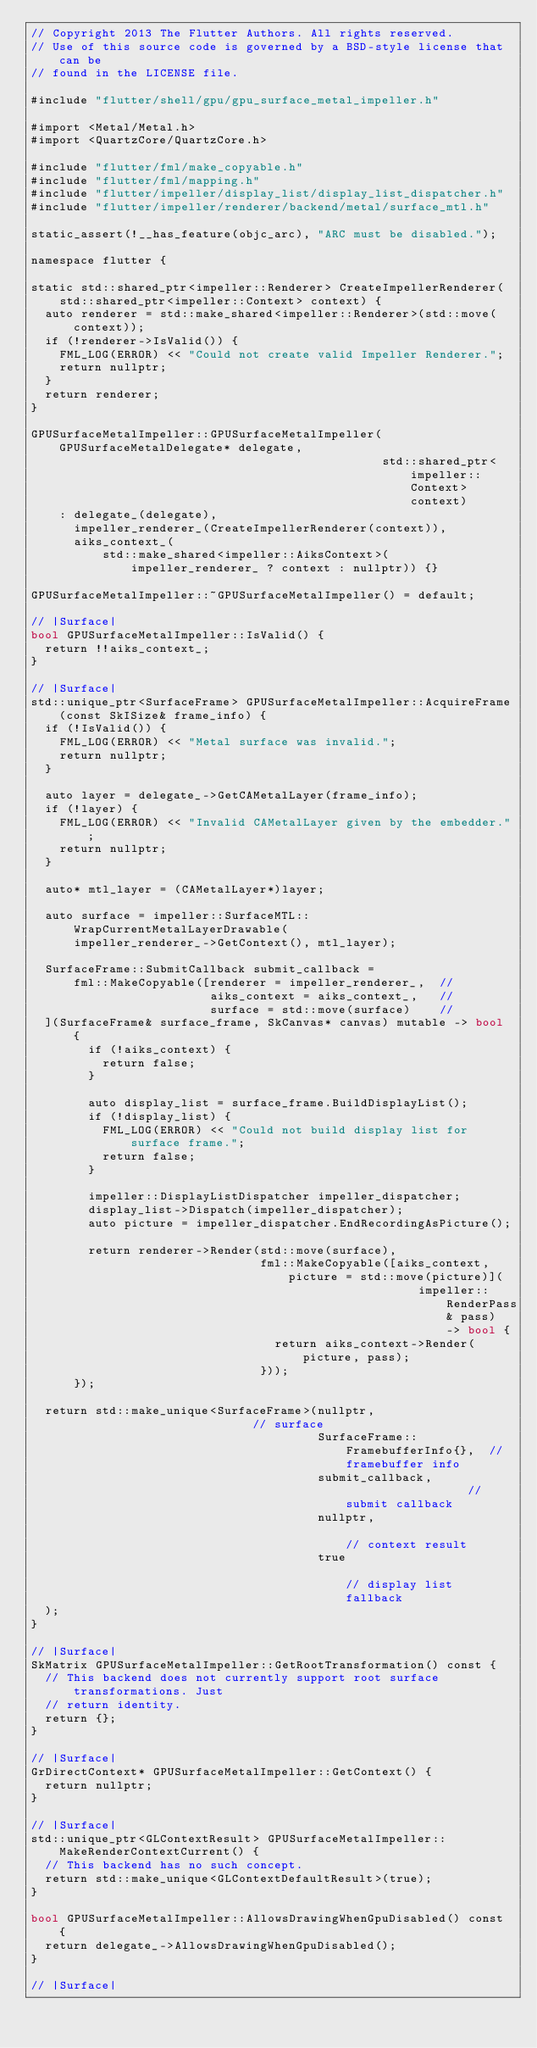Convert code to text. <code><loc_0><loc_0><loc_500><loc_500><_ObjectiveC_>// Copyright 2013 The Flutter Authors. All rights reserved.
// Use of this source code is governed by a BSD-style license that can be
// found in the LICENSE file.

#include "flutter/shell/gpu/gpu_surface_metal_impeller.h"

#import <Metal/Metal.h>
#import <QuartzCore/QuartzCore.h>

#include "flutter/fml/make_copyable.h"
#include "flutter/fml/mapping.h"
#include "flutter/impeller/display_list/display_list_dispatcher.h"
#include "flutter/impeller/renderer/backend/metal/surface_mtl.h"

static_assert(!__has_feature(objc_arc), "ARC must be disabled.");

namespace flutter {

static std::shared_ptr<impeller::Renderer> CreateImpellerRenderer(
    std::shared_ptr<impeller::Context> context) {
  auto renderer = std::make_shared<impeller::Renderer>(std::move(context));
  if (!renderer->IsValid()) {
    FML_LOG(ERROR) << "Could not create valid Impeller Renderer.";
    return nullptr;
  }
  return renderer;
}

GPUSurfaceMetalImpeller::GPUSurfaceMetalImpeller(GPUSurfaceMetalDelegate* delegate,
                                                 std::shared_ptr<impeller::Context> context)
    : delegate_(delegate),
      impeller_renderer_(CreateImpellerRenderer(context)),
      aiks_context_(
          std::make_shared<impeller::AiksContext>(impeller_renderer_ ? context : nullptr)) {}

GPUSurfaceMetalImpeller::~GPUSurfaceMetalImpeller() = default;

// |Surface|
bool GPUSurfaceMetalImpeller::IsValid() {
  return !!aiks_context_;
}

// |Surface|
std::unique_ptr<SurfaceFrame> GPUSurfaceMetalImpeller::AcquireFrame(const SkISize& frame_info) {
  if (!IsValid()) {
    FML_LOG(ERROR) << "Metal surface was invalid.";
    return nullptr;
  }

  auto layer = delegate_->GetCAMetalLayer(frame_info);
  if (!layer) {
    FML_LOG(ERROR) << "Invalid CAMetalLayer given by the embedder.";
    return nullptr;
  }

  auto* mtl_layer = (CAMetalLayer*)layer;

  auto surface = impeller::SurfaceMTL::WrapCurrentMetalLayerDrawable(
      impeller_renderer_->GetContext(), mtl_layer);

  SurfaceFrame::SubmitCallback submit_callback =
      fml::MakeCopyable([renderer = impeller_renderer_,  //
                         aiks_context = aiks_context_,   //
                         surface = std::move(surface)    //
  ](SurfaceFrame& surface_frame, SkCanvas* canvas) mutable -> bool {
        if (!aiks_context) {
          return false;
        }

        auto display_list = surface_frame.BuildDisplayList();
        if (!display_list) {
          FML_LOG(ERROR) << "Could not build display list for surface frame.";
          return false;
        }

        impeller::DisplayListDispatcher impeller_dispatcher;
        display_list->Dispatch(impeller_dispatcher);
        auto picture = impeller_dispatcher.EndRecordingAsPicture();

        return renderer->Render(std::move(surface),
                                fml::MakeCopyable([aiks_context, picture = std::move(picture)](
                                                      impeller::RenderPass& pass) -> bool {
                                  return aiks_context->Render(picture, pass);
                                }));
      });

  return std::make_unique<SurfaceFrame>(nullptr,                          // surface
                                        SurfaceFrame::FramebufferInfo{},  // framebuffer info
                                        submit_callback,                  // submit callback
                                        nullptr,                          // context result
                                        true                              // display list fallback
  );
}

// |Surface|
SkMatrix GPUSurfaceMetalImpeller::GetRootTransformation() const {
  // This backend does not currently support root surface transformations. Just
  // return identity.
  return {};
}

// |Surface|
GrDirectContext* GPUSurfaceMetalImpeller::GetContext() {
  return nullptr;
}

// |Surface|
std::unique_ptr<GLContextResult> GPUSurfaceMetalImpeller::MakeRenderContextCurrent() {
  // This backend has no such concept.
  return std::make_unique<GLContextDefaultResult>(true);
}

bool GPUSurfaceMetalImpeller::AllowsDrawingWhenGpuDisabled() const {
  return delegate_->AllowsDrawingWhenGpuDisabled();
}

// |Surface|</code> 